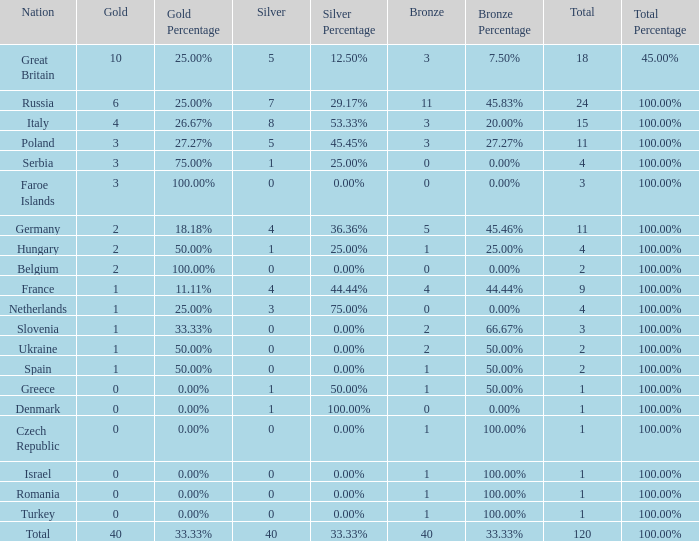What is the average Gold entry for the Netherlands that also has a Bronze entry that is greater than 0? None. 